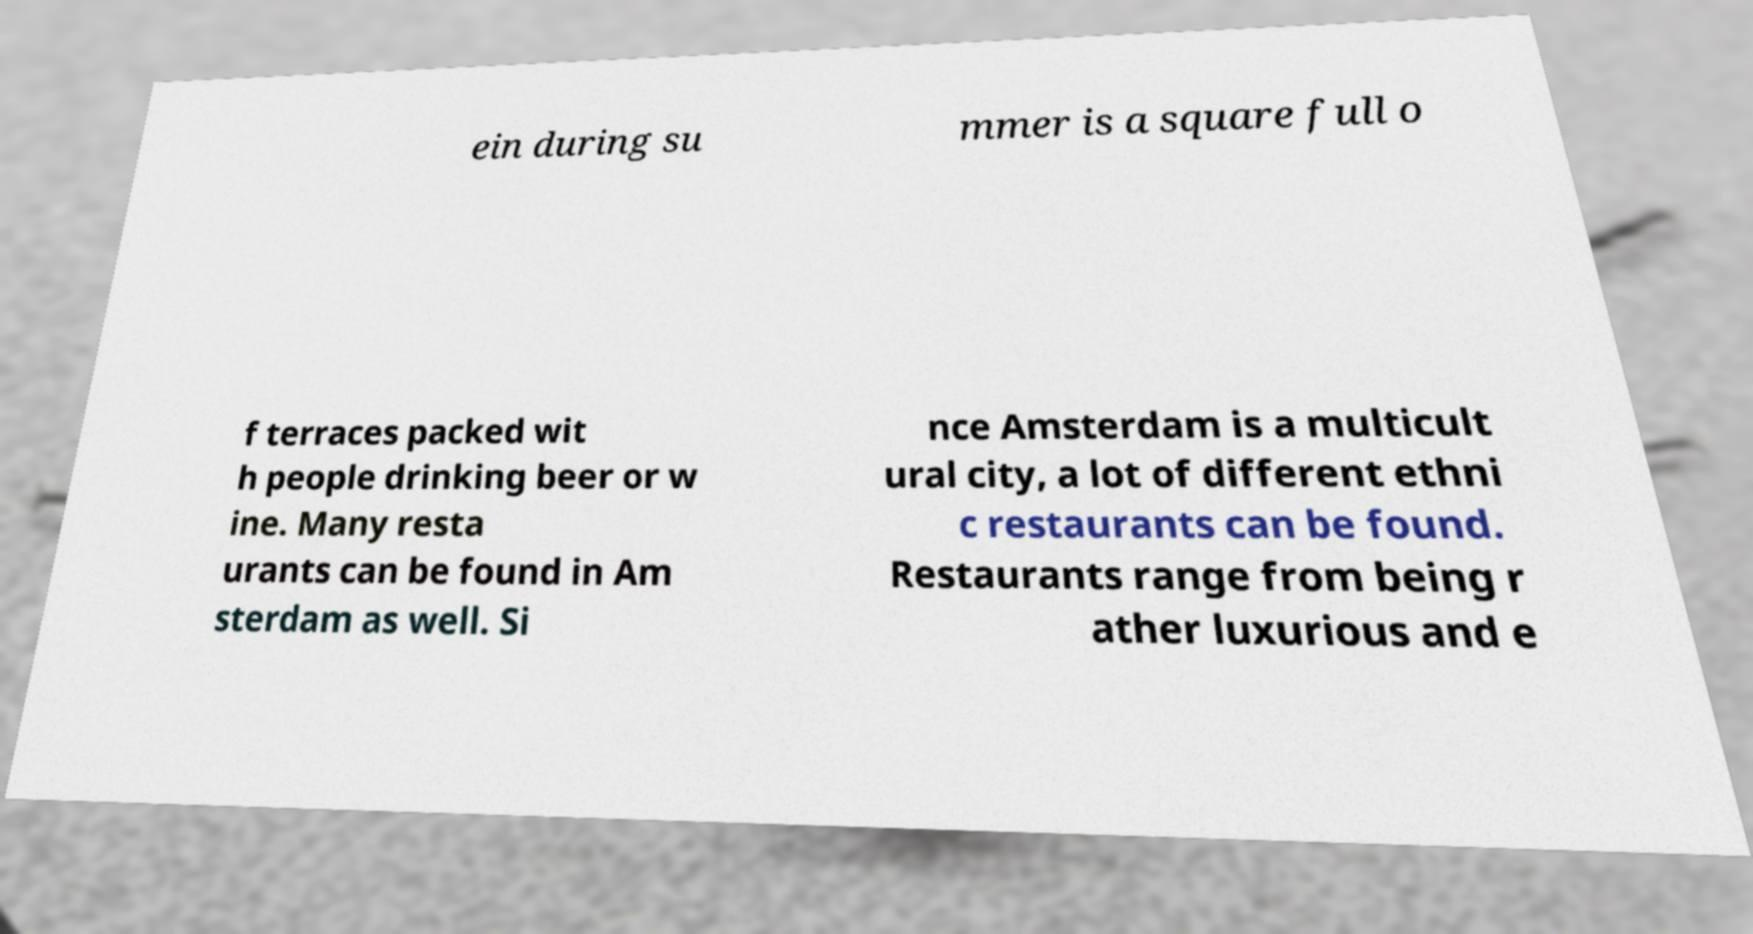I need the written content from this picture converted into text. Can you do that? ein during su mmer is a square full o f terraces packed wit h people drinking beer or w ine. Many resta urants can be found in Am sterdam as well. Si nce Amsterdam is a multicult ural city, a lot of different ethni c restaurants can be found. Restaurants range from being r ather luxurious and e 